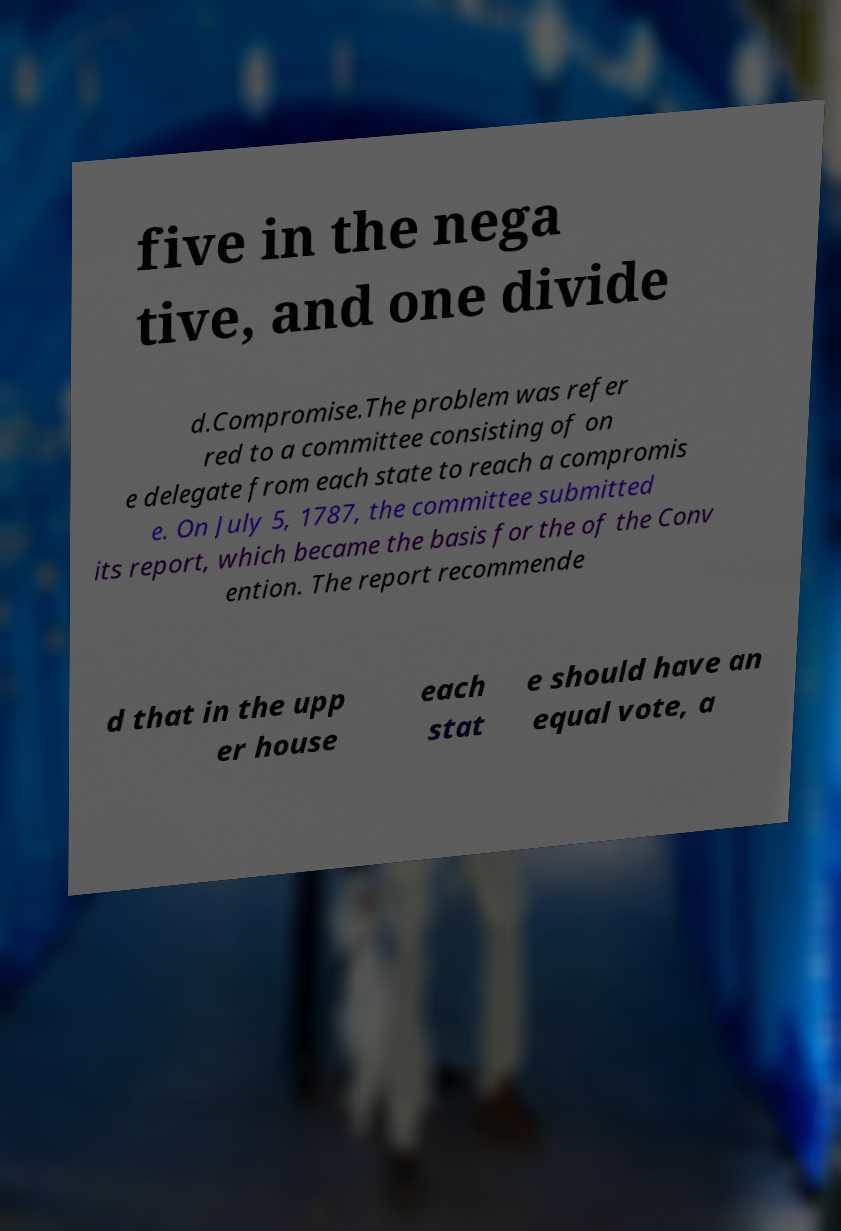What messages or text are displayed in this image? I need them in a readable, typed format. five in the nega tive, and one divide d.Compromise.The problem was refer red to a committee consisting of on e delegate from each state to reach a compromis e. On July 5, 1787, the committee submitted its report, which became the basis for the of the Conv ention. The report recommende d that in the upp er house each stat e should have an equal vote, a 